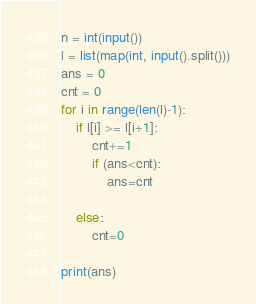Convert code to text. <code><loc_0><loc_0><loc_500><loc_500><_Python_>n = int(input())
l = list(map(int, input().split()))
ans = 0
cnt = 0
for i in range(len(l)-1):
    if l[i] >= l[i+1]:
        cnt+=1
        if (ans<cnt):
            ans=cnt

    else:
        cnt=0

print(ans)</code> 